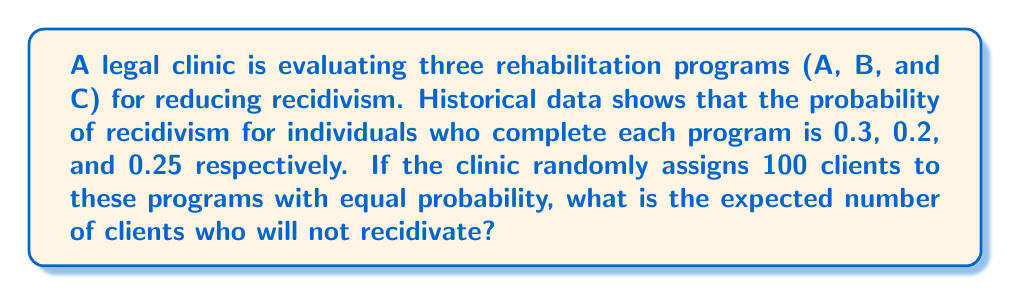Can you solve this math problem? Let's approach this step-by-step:

1) First, we need to calculate the probability of a client being assigned to each program:
   $P(A) = P(B) = P(C) = \frac{1}{3}$

2) Now, let's calculate the probability of not recidivating for each program:
   Program A: $P(\text{not recidivate}|A) = 1 - 0.3 = 0.7$
   Program B: $P(\text{not recidivate}|B) = 1 - 0.2 = 0.8$
   Program C: $P(\text{not recidivate}|C) = 1 - 0.25 = 0.75$

3) The overall probability of not recidivating can be calculated using the law of total probability:

   $$P(\text{not recidivate}) = P(A) \cdot P(\text{not recidivate}|A) + P(B) \cdot P(\text{not recidivate}|B) + P(C) \cdot P(\text{not recidivate}|C)$$

4) Substituting the values:

   $$P(\text{not recidivate}) = \frac{1}{3} \cdot 0.7 + \frac{1}{3} \cdot 0.8 + \frac{1}{3} \cdot 0.75 = \frac{0.7 + 0.8 + 0.75}{3} = \frac{2.25}{3} = 0.75$$

5) The expected number of clients who will not recidivate out of 100 is:

   $$E(\text{not recidivate}) = 100 \cdot P(\text{not recidivate}) = 100 \cdot 0.75 = 75$$

Therefore, the expected number of clients who will not recidivate is 75.
Answer: 75 clients 